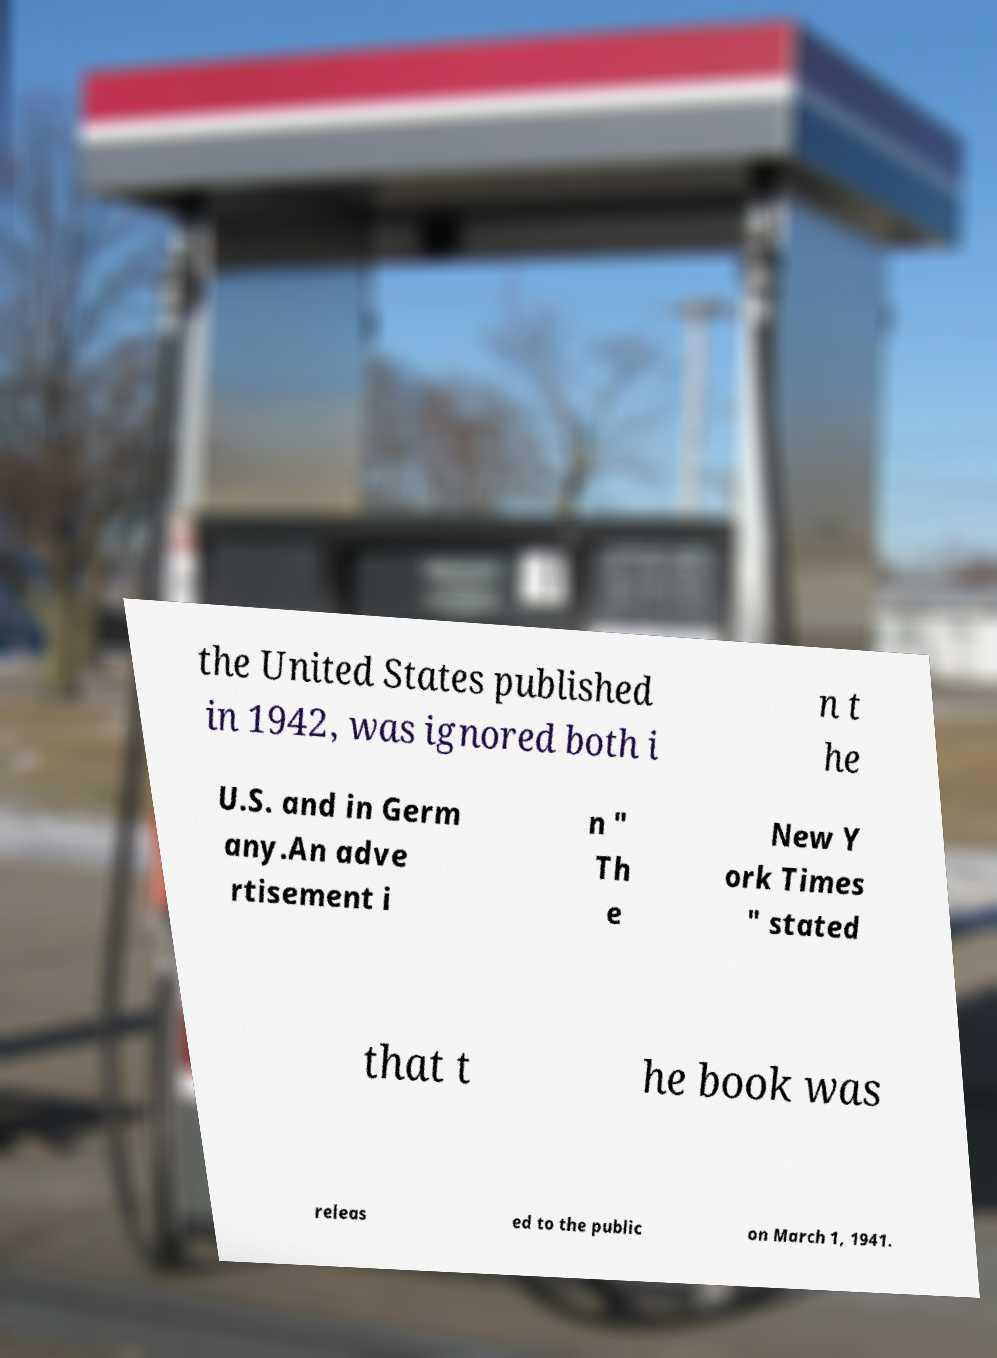Could you extract and type out the text from this image? the United States published in 1942, was ignored both i n t he U.S. and in Germ any.An adve rtisement i n " Th e New Y ork Times " stated that t he book was releas ed to the public on March 1, 1941. 